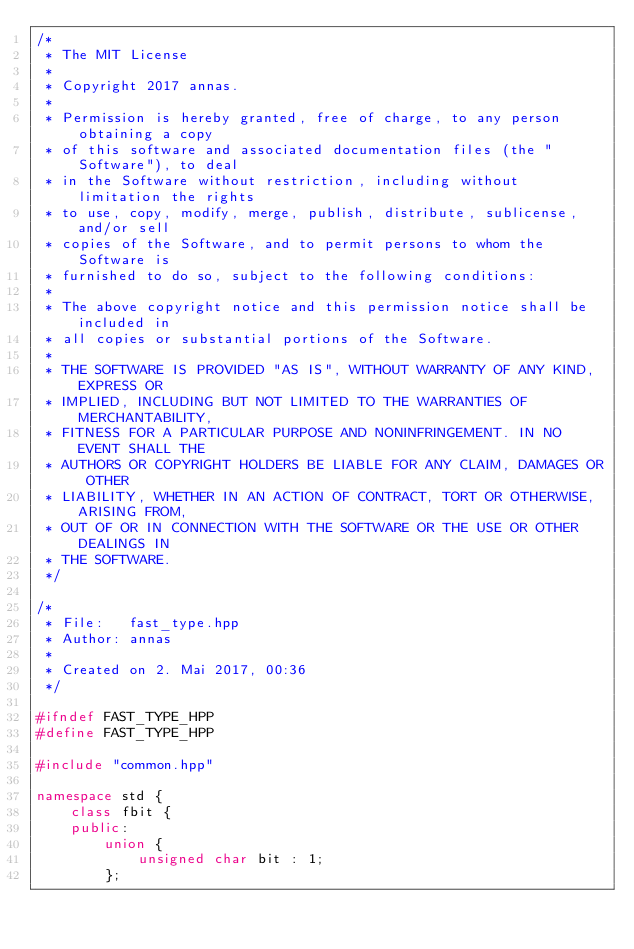<code> <loc_0><loc_0><loc_500><loc_500><_C++_>/*
 * The MIT License
 *
 * Copyright 2017 annas.
 *
 * Permission is hereby granted, free of charge, to any person obtaining a copy
 * of this software and associated documentation files (the "Software"), to deal
 * in the Software without restriction, including without limitation the rights
 * to use, copy, modify, merge, publish, distribute, sublicense, and/or sell
 * copies of the Software, and to permit persons to whom the Software is
 * furnished to do so, subject to the following conditions:
 *
 * The above copyright notice and this permission notice shall be included in
 * all copies or substantial portions of the Software.
 *
 * THE SOFTWARE IS PROVIDED "AS IS", WITHOUT WARRANTY OF ANY KIND, EXPRESS OR
 * IMPLIED, INCLUDING BUT NOT LIMITED TO THE WARRANTIES OF MERCHANTABILITY,
 * FITNESS FOR A PARTICULAR PURPOSE AND NONINFRINGEMENT. IN NO EVENT SHALL THE
 * AUTHORS OR COPYRIGHT HOLDERS BE LIABLE FOR ANY CLAIM, DAMAGES OR OTHER
 * LIABILITY, WHETHER IN AN ACTION OF CONTRACT, TORT OR OTHERWISE, ARISING FROM,
 * OUT OF OR IN CONNECTION WITH THE SOFTWARE OR THE USE OR OTHER DEALINGS IN
 * THE SOFTWARE.
 */

/* 
 * File:   fast_type.hpp
 * Author: annas
 *
 * Created on 2. Mai 2017, 00:36
 */

#ifndef FAST_TYPE_HPP
#define FAST_TYPE_HPP

#include "common.hpp"

namespace std {
    class fbit {
    public:
        union {
            unsigned char bit : 1;
        };</code> 